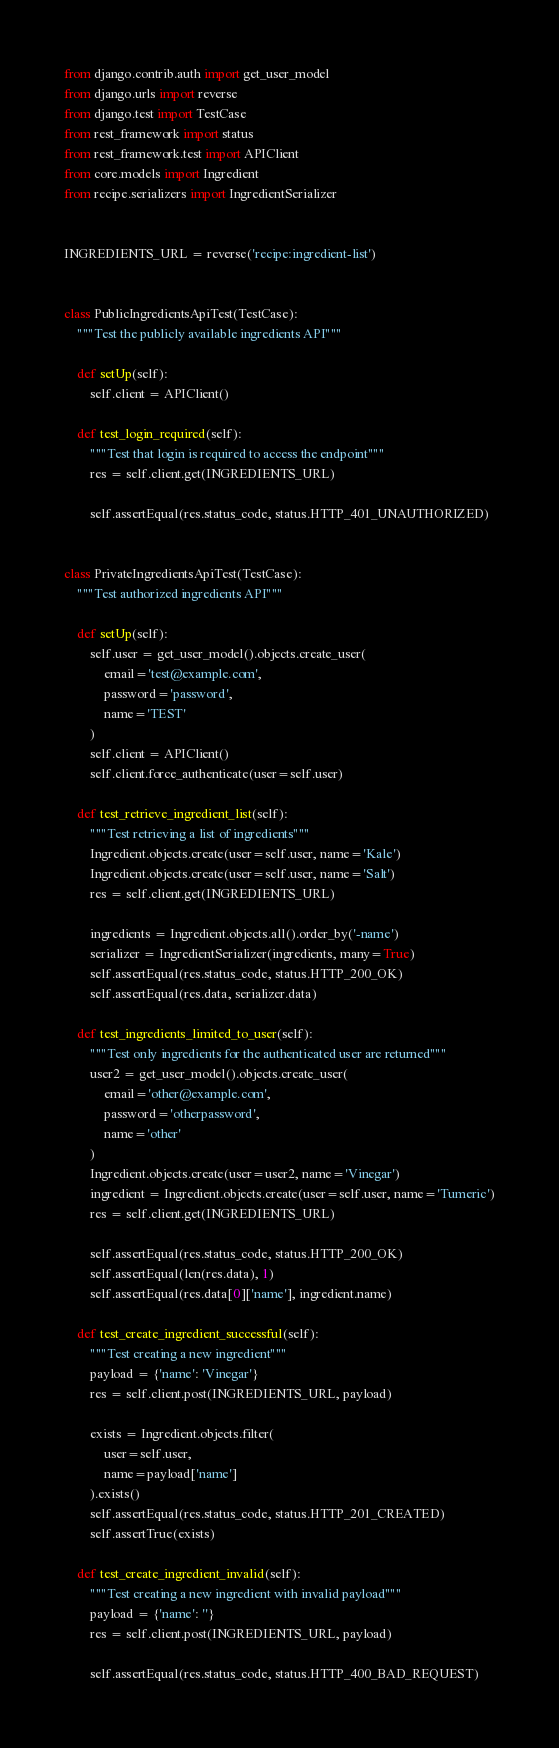<code> <loc_0><loc_0><loc_500><loc_500><_Python_>from django.contrib.auth import get_user_model
from django.urls import reverse
from django.test import TestCase
from rest_framework import status
from rest_framework.test import APIClient
from core.models import Ingredient
from recipe.serializers import IngredientSerializer


INGREDIENTS_URL = reverse('recipe:ingredient-list')


class PublicIngredientsApiTest(TestCase):
    """Test the publicly available ingredients API"""

    def setUp(self):
        self.client = APIClient()

    def test_login_required(self):
        """Test that login is required to access the endpoint"""
        res = self.client.get(INGREDIENTS_URL)

        self.assertEqual(res.status_code, status.HTTP_401_UNAUTHORIZED)


class PrivateIngredientsApiTest(TestCase):
    """Test authorized ingredients API"""

    def setUp(self):
        self.user = get_user_model().objects.create_user(
            email='test@example.com',
            password='password',
            name='TEST'
        )
        self.client = APIClient()
        self.client.force_authenticate(user=self.user)

    def test_retrieve_ingredient_list(self):
        """Test retrieving a list of ingredients"""
        Ingredient.objects.create(user=self.user, name='Kale')
        Ingredient.objects.create(user=self.user, name='Salt')
        res = self.client.get(INGREDIENTS_URL)

        ingredients = Ingredient.objects.all().order_by('-name')
        serializer = IngredientSerializer(ingredients, many=True)
        self.assertEqual(res.status_code, status.HTTP_200_OK)
        self.assertEqual(res.data, serializer.data)

    def test_ingredients_limited_to_user(self):
        """Test only ingredients for the authenticated user are returned"""
        user2 = get_user_model().objects.create_user(
            email='other@example.com',
            password='otherpassword',
            name='other'
        )
        Ingredient.objects.create(user=user2, name='Vinegar')
        ingredient = Ingredient.objects.create(user=self.user, name='Tumeric')
        res = self.client.get(INGREDIENTS_URL)

        self.assertEqual(res.status_code, status.HTTP_200_OK)
        self.assertEqual(len(res.data), 1)
        self.assertEqual(res.data[0]['name'], ingredient.name)

    def test_create_ingredient_successful(self):
        """Test creating a new ingredient"""
        payload = {'name': 'Vinegar'}
        res = self.client.post(INGREDIENTS_URL, payload)

        exists = Ingredient.objects.filter(
            user=self.user,
            name=payload['name']
        ).exists()
        self.assertEqual(res.status_code, status.HTTP_201_CREATED)
        self.assertTrue(exists)

    def test_create_ingredient_invalid(self):
        """Test creating a new ingredient with invalid payload"""
        payload = {'name': ''}
        res = self.client.post(INGREDIENTS_URL, payload)

        self.assertEqual(res.status_code, status.HTTP_400_BAD_REQUEST)
</code> 